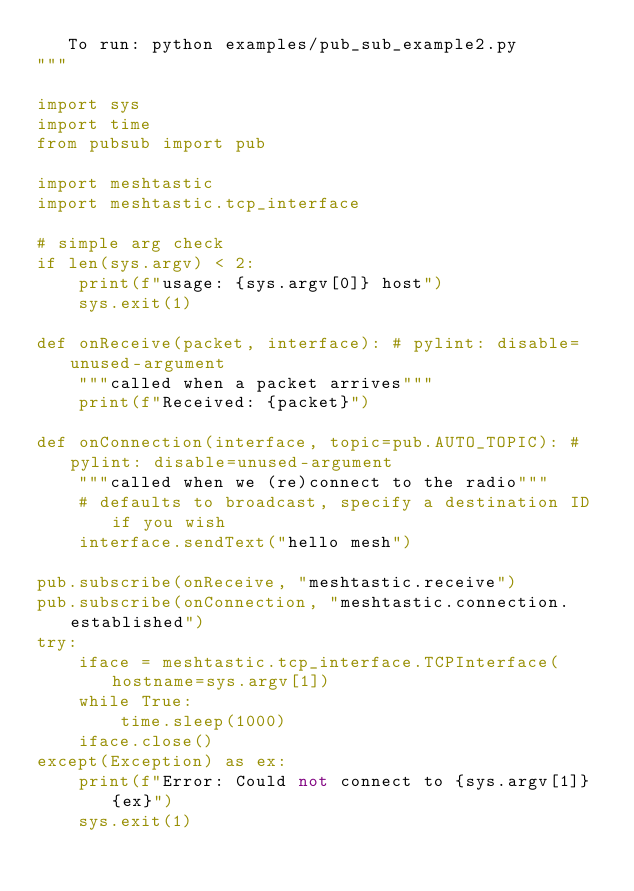Convert code to text. <code><loc_0><loc_0><loc_500><loc_500><_Python_>   To run: python examples/pub_sub_example2.py
"""

import sys
import time
from pubsub import pub

import meshtastic
import meshtastic.tcp_interface

# simple arg check
if len(sys.argv) < 2:
    print(f"usage: {sys.argv[0]} host")
    sys.exit(1)

def onReceive(packet, interface): # pylint: disable=unused-argument
    """called when a packet arrives"""
    print(f"Received: {packet}")

def onConnection(interface, topic=pub.AUTO_TOPIC): # pylint: disable=unused-argument
    """called when we (re)connect to the radio"""
    # defaults to broadcast, specify a destination ID if you wish
    interface.sendText("hello mesh")

pub.subscribe(onReceive, "meshtastic.receive")
pub.subscribe(onConnection, "meshtastic.connection.established")
try:
    iface = meshtastic.tcp_interface.TCPInterface(hostname=sys.argv[1])
    while True:
        time.sleep(1000)
    iface.close()
except(Exception) as ex:
    print(f"Error: Could not connect to {sys.argv[1]} {ex}")
    sys.exit(1)
</code> 